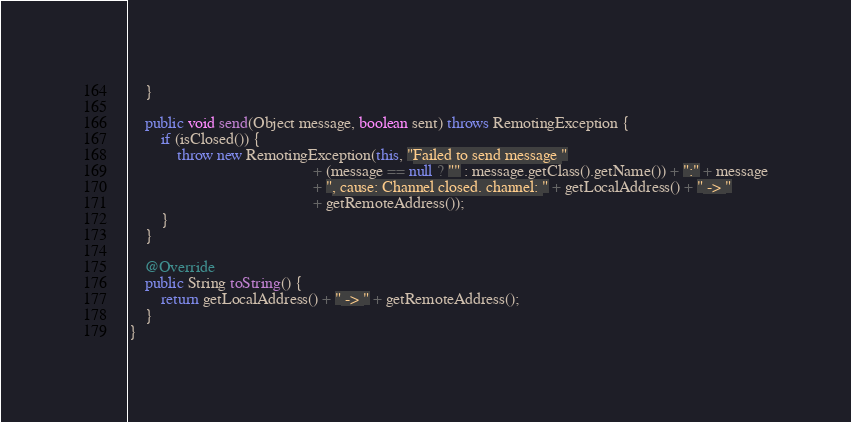<code> <loc_0><loc_0><loc_500><loc_500><_Java_>    }

    public void send(Object message, boolean sent) throws RemotingException {
        if (isClosed()) {
            throw new RemotingException(this, "Failed to send message "
                                              + (message == null ? "" : message.getClass().getName()) + ":" + message
                                              + ", cause: Channel closed. channel: " + getLocalAddress() + " -> "
                                              + getRemoteAddress());
        }
    }

    @Override
    public String toString() {
        return getLocalAddress() + " -> " + getRemoteAddress();
    }
}
</code> 